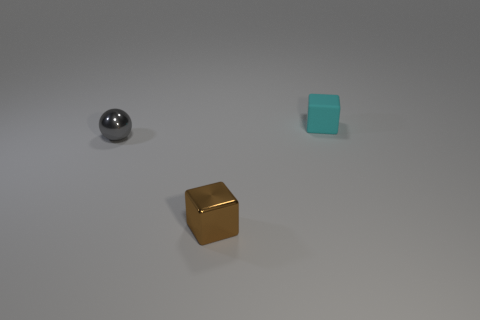Add 3 purple cylinders. How many objects exist? 6 Subtract all cubes. How many objects are left? 1 Add 2 tiny objects. How many tiny objects exist? 5 Subtract 0 green spheres. How many objects are left? 3 Subtract all gray cubes. Subtract all red spheres. How many cubes are left? 2 Subtract all small brown cubes. Subtract all large blue matte cylinders. How many objects are left? 2 Add 1 brown shiny cubes. How many brown shiny cubes are left? 2 